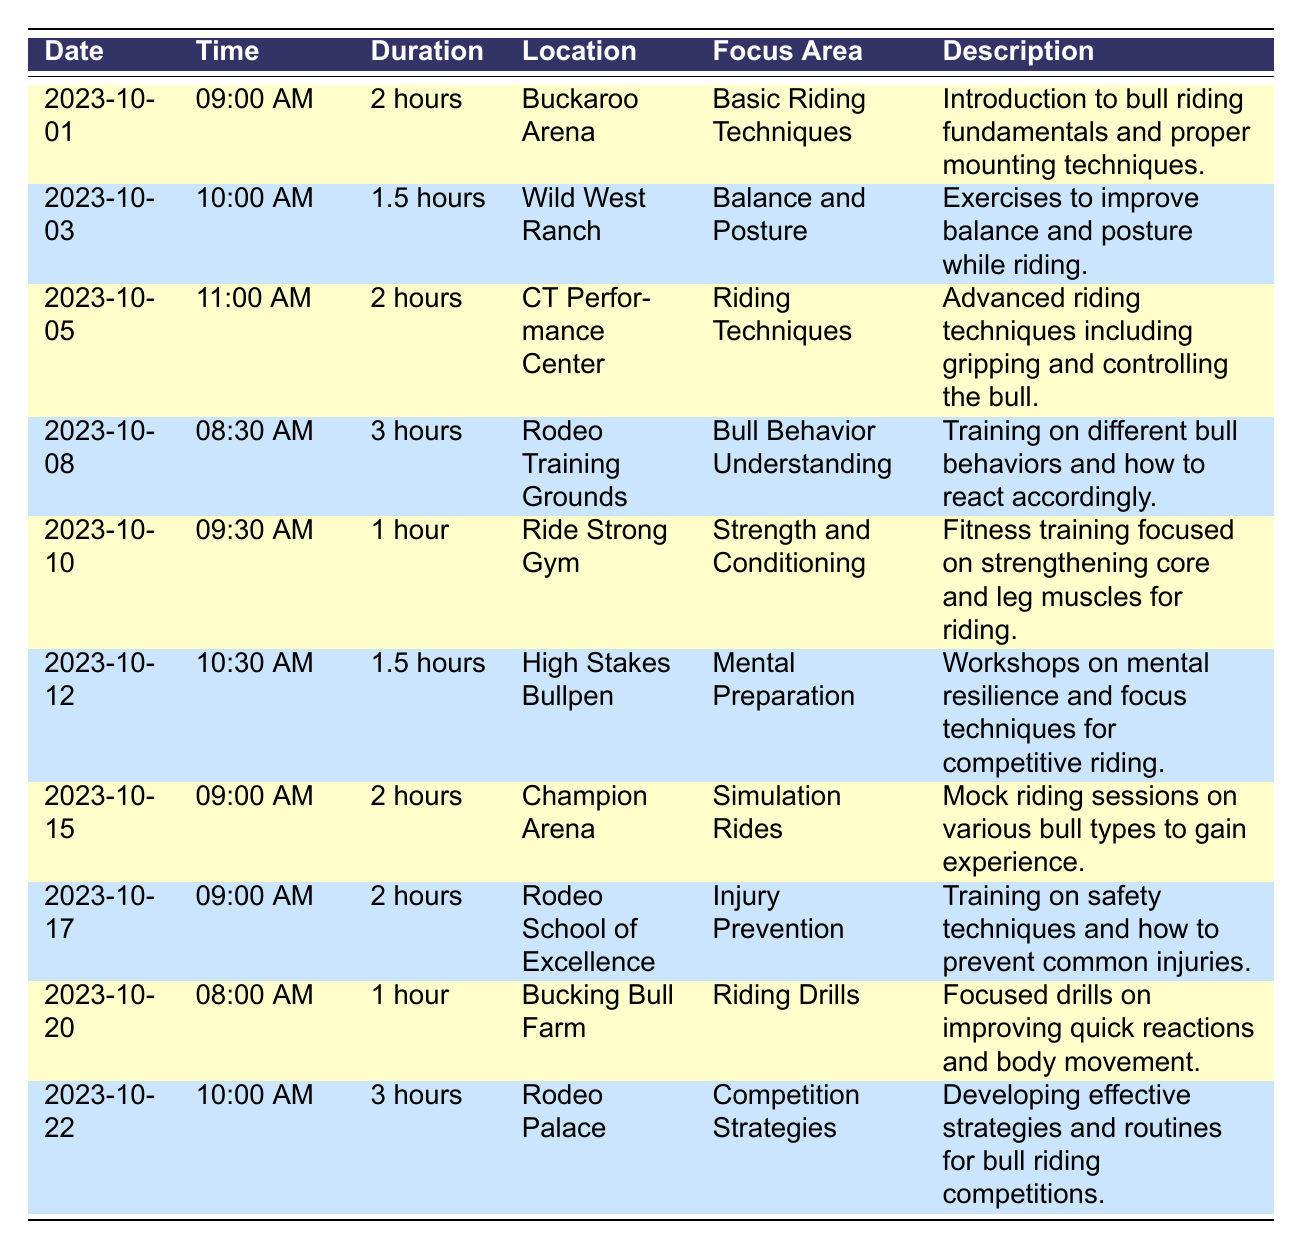What is the focus area of the training session on October 5, 2023? The focus area for the session on October 5, 2023, is listed as "Riding Techniques." This information can be found by locating the row corresponding to that date in the table and reading the relevant column.
Answer: Riding Techniques How long is the session on mental preparation? The duration of the mental preparation session on October 12, 2023, is specified as "1.5 hours" in the duration column of the corresponding row.
Answer: 1.5 hours Which training session is the longest in duration? To determine the longest session, we can examine the duration column. The session on October 8, 2023, has a duration of "3 hours," which is more than the other sessions listed. It's the only one with this duration.
Answer: 3 hours Are there any training sessions focused on injury prevention? Yes, there is a session on injury prevention identified on October 17, 2023, under the focus area in the corresponding row. This indicates that training related to safety and injury prevention is scheduled.
Answer: Yes What is the average duration of the training sessions? First, we identify the durations: 2, 1.5, 2, 3, 1, 1.5, 2, 2, 1, 3. We sum these values: 2 + 1.5 + 2 + 3 + 1 + 1.5 + 2 + 2 + 1 + 3 = 20. Then, we divide the total by the number of sessions (10): 20/10 = 2. So, the average duration is 2 hours.
Answer: 2 hours How many sessions take place in the Buckaroo Arena? By reviewing the location column, we can see there are two sessions located at Buckaroo Arena: the one on October 1 and the one on October 20. Thus, the count of sessions is 2.
Answer: 2 sessions 